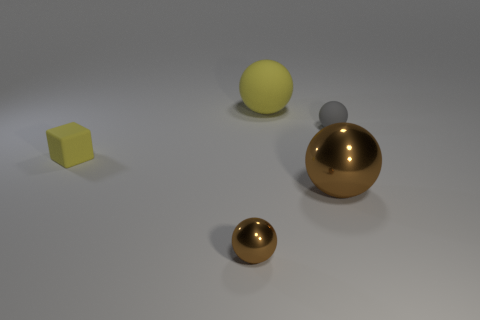Add 5 big yellow metal objects. How many objects exist? 10 Subtract all blue spheres. Subtract all brown cylinders. How many spheres are left? 4 Subtract all spheres. How many objects are left? 1 Add 3 tiny matte spheres. How many tiny matte spheres exist? 4 Subtract 0 red spheres. How many objects are left? 5 Subtract all small metallic objects. Subtract all shiny things. How many objects are left? 2 Add 5 big brown metallic objects. How many big brown metallic objects are left? 6 